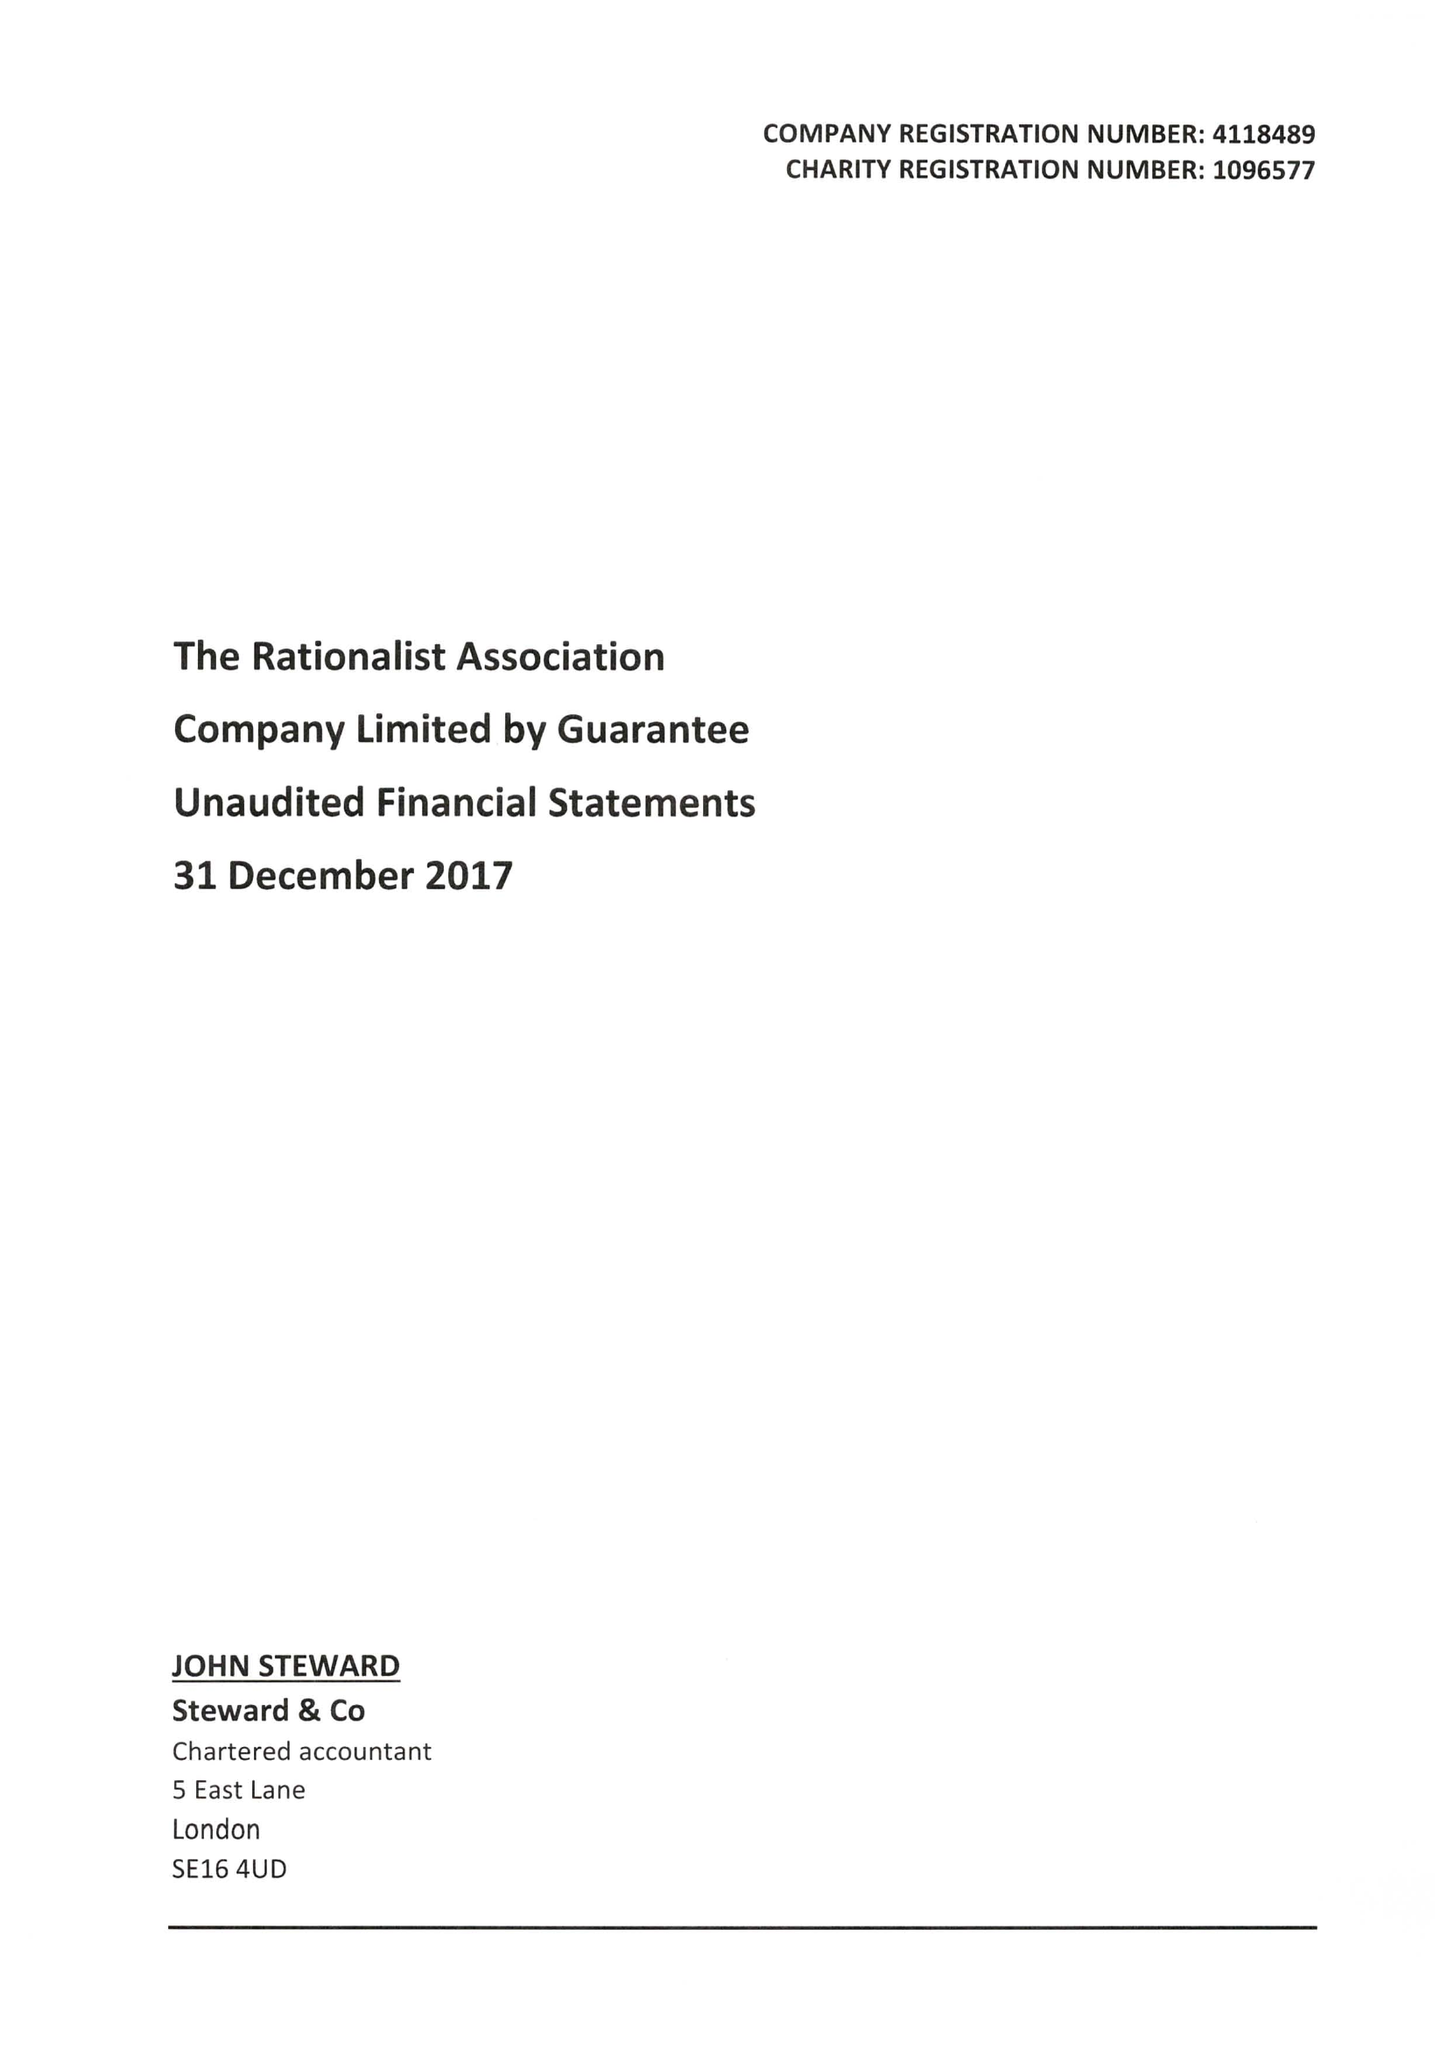What is the value for the address__post_town?
Answer the question using a single word or phrase. LONDON 